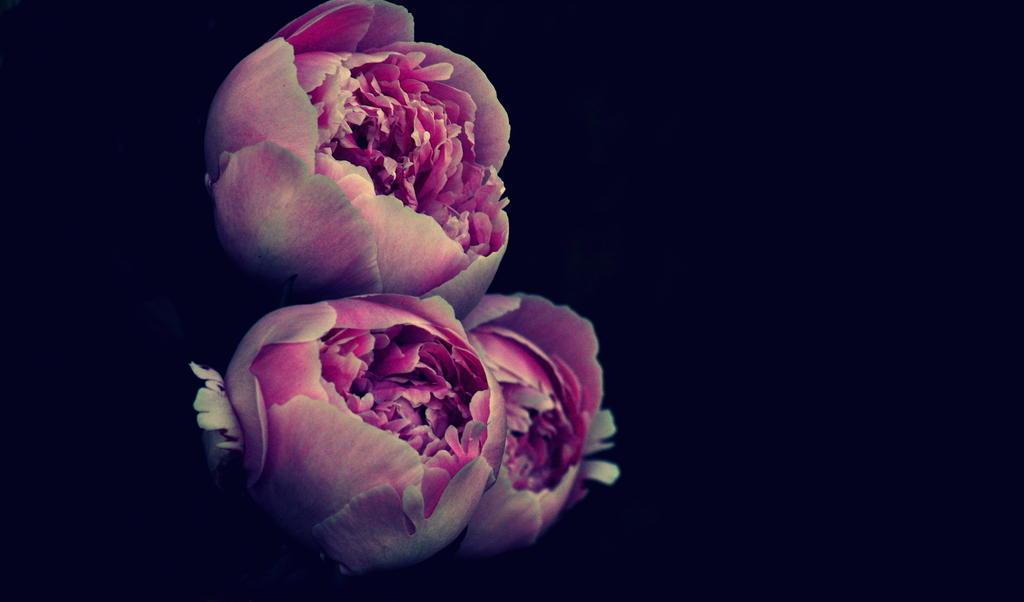How many flowers are present in the image? There are three flowers in the image. What can be observed about the background of the image? The background of the image is dark. What type of meat is being served on a plate in the image? There is no plate or meat present in the image; it only features three flowers and a dark background. 